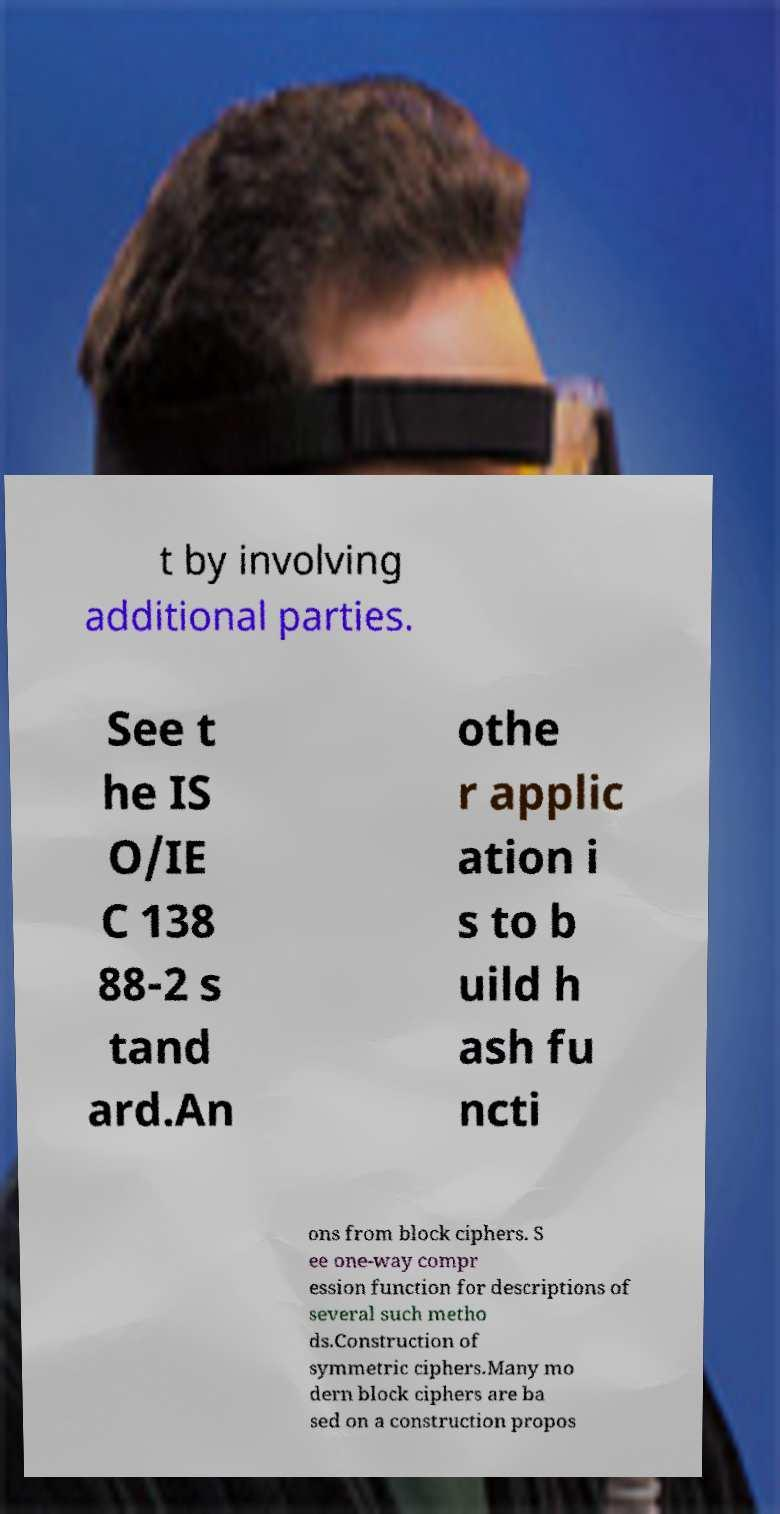Could you extract and type out the text from this image? t by involving additional parties. See t he IS O/IE C 138 88-2 s tand ard.An othe r applic ation i s to b uild h ash fu ncti ons from block ciphers. S ee one-way compr ession function for descriptions of several such metho ds.Construction of symmetric ciphers.Many mo dern block ciphers are ba sed on a construction propos 